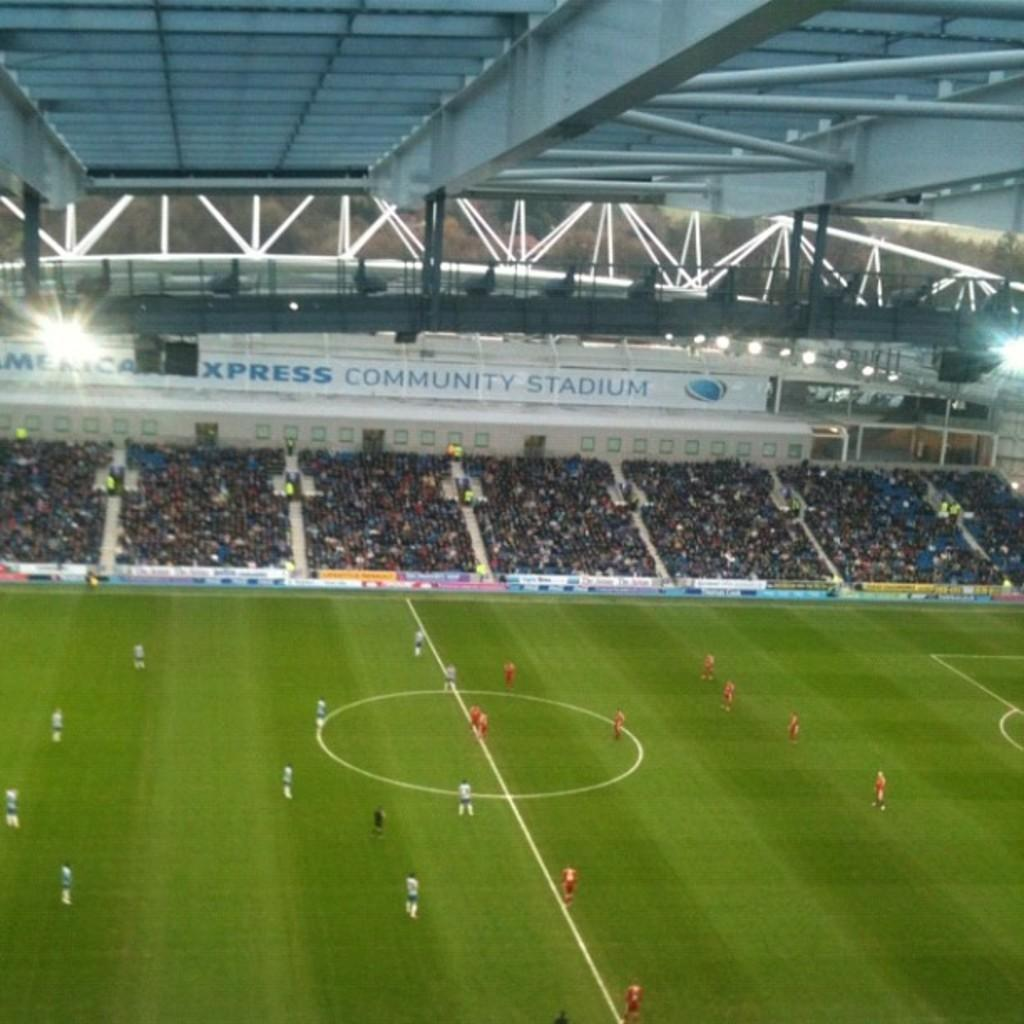<image>
Provide a brief description of the given image. A crowd watches a sports game at the American Express Community Stadium. 